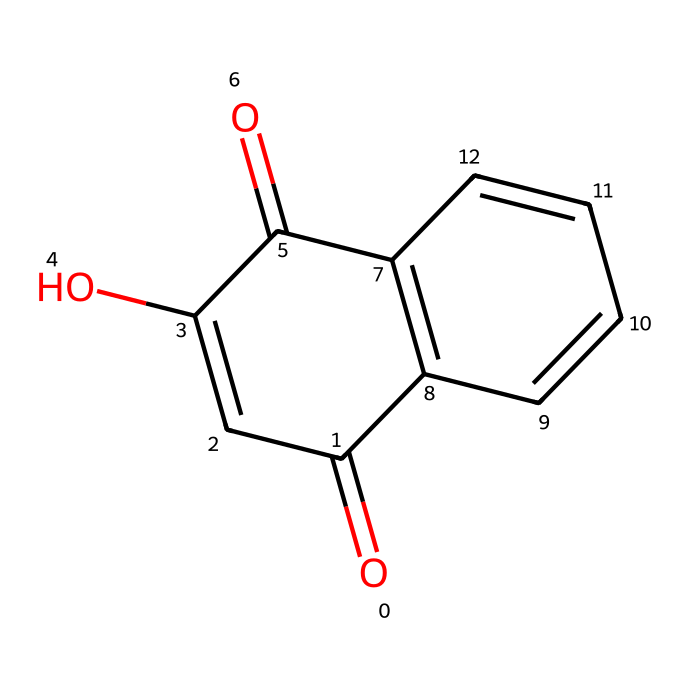What is the molecular formula of the compound represented by this SMILES? To determine the molecular formula, we analyze the SMILES notation, identifying the atoms present. Counting the carbon (C), oxygen (O), and hydrogen (H) atoms yields a total of 10 carbon atoms, 6 hydrogen atoms, and 4 oxygen atoms. Thus, the molecular formula is C10H6O4.
Answer: C10H6O4 How many rings are present in the structure? We can spot rings by looking for connections where carbon atoms form a closed loop in the structure. In this case, there are two distinct ring systems visible based on the connections in the SMILES. Therefore, there are two rings in the structure.
Answer: 2 What functional groups are present in this dye? To identify functional groups, we look at the specific arrangements of atoms and bonds in the structure. The presence of carbonyl groups (C=O) and hydroxyl groups (–OH) can be noted in the structure, indicating that the dye contains both carbonyl (ketone or aldehyde) and alcohol functional groups.
Answer: carbonyls and hydroxyls Is this structure likely to be soluble in water? To assess solubility, we consider the functional groups present and the overall polarity of the molecule. The hydroxyl groups introduce polarity, which often enhances water solubility. Coupled with the structure's overall characteristics, it suggests some level of water solubility.
Answer: yes What color is this dye typically associated with? The color associated with the dye derived from this chemical structure is commonly known to yield a reddish-brown hue, primarily attributed to the properties of the active compound (lawsone) in henna used for dyeing.
Answer: reddish-brown Does this dye have any known uses in alternative therapies? By analyzing the structure of this dye derived from henna, it is indeed well-documented for use in alternative therapies, particularly for natural body art and traditional herbal treatments, reflecting its historical significance in cultural practices.
Answer: yes 